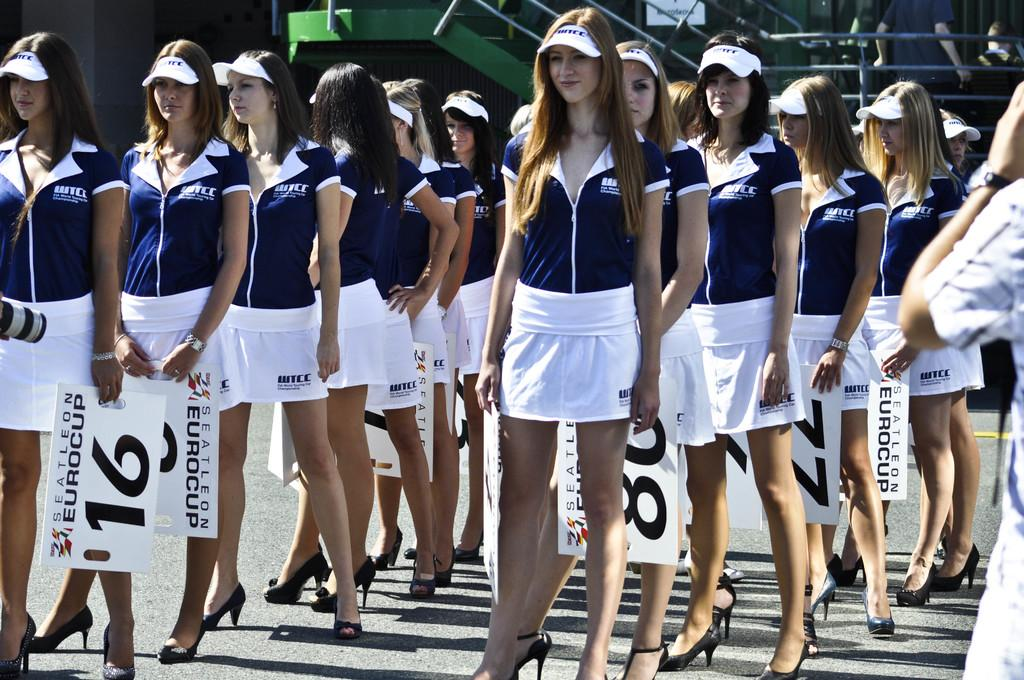<image>
Summarize the visual content of the image. A group of pretty women hold numbered signs for the Eurocup. 